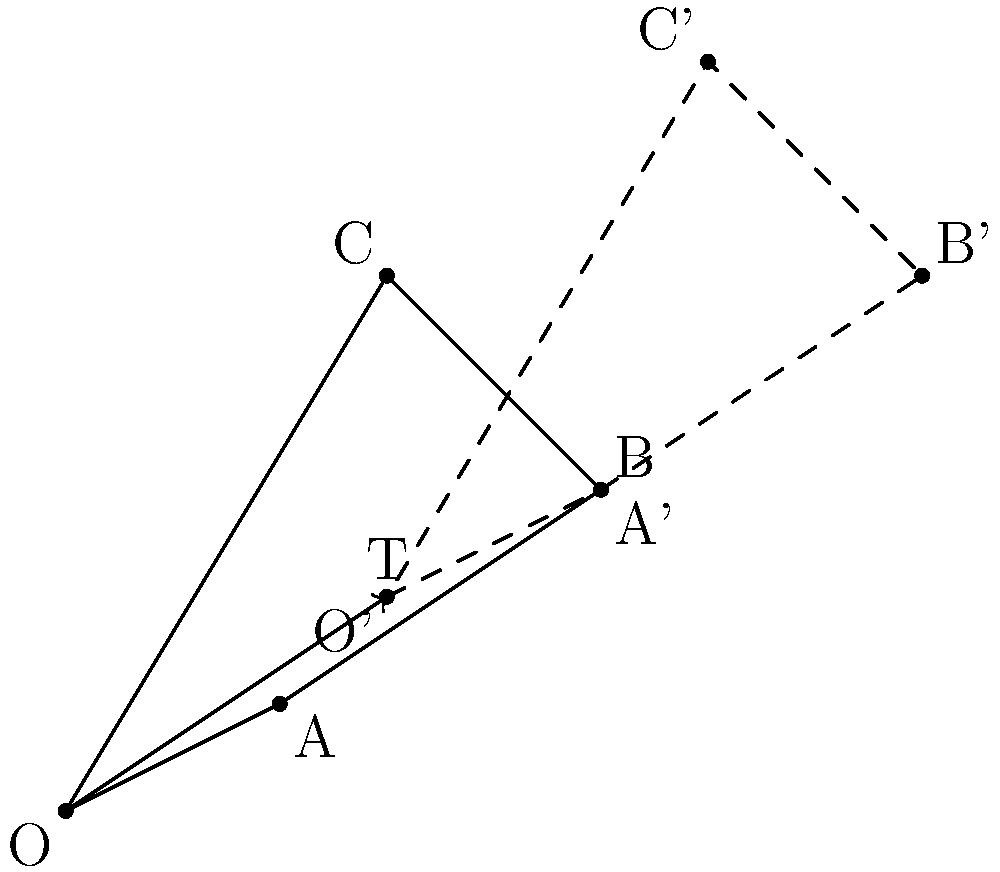A space probe's position relative to a planetary body is represented by the quadrilateral OABC. If the probe's position is translated by vector $T(3,2)$, what are the coordinates of point B' after the translation? To find the coordinates of point B' after the translation, we need to follow these steps:

1. Identify the original coordinates of point B:
   From the diagram, we can see that B has coordinates (5,3).

2. Understand the translation vector:
   The translation vector is given as $T(3,2)$, which means we need to add 3 to the x-coordinate and 2 to the y-coordinate.

3. Apply the translation:
   - x-coordinate of B': $5 + 3 = 8$
   - y-coordinate of B': $3 + 2 = 5$

4. Combine the new coordinates:
   After translation, B' has coordinates (8,5).

The translation can be represented mathematically as:
$B'_x = B_x + T_x = 5 + 3 = 8$
$B'_y = B_y + T_y = 3 + 2 = 5$

Therefore, the coordinates of point B' after the translation are (8,5).
Answer: (8,5) 